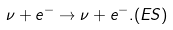<formula> <loc_0><loc_0><loc_500><loc_500>\nu + e ^ { - } \rightarrow \nu + e ^ { - } . ( E S )</formula> 